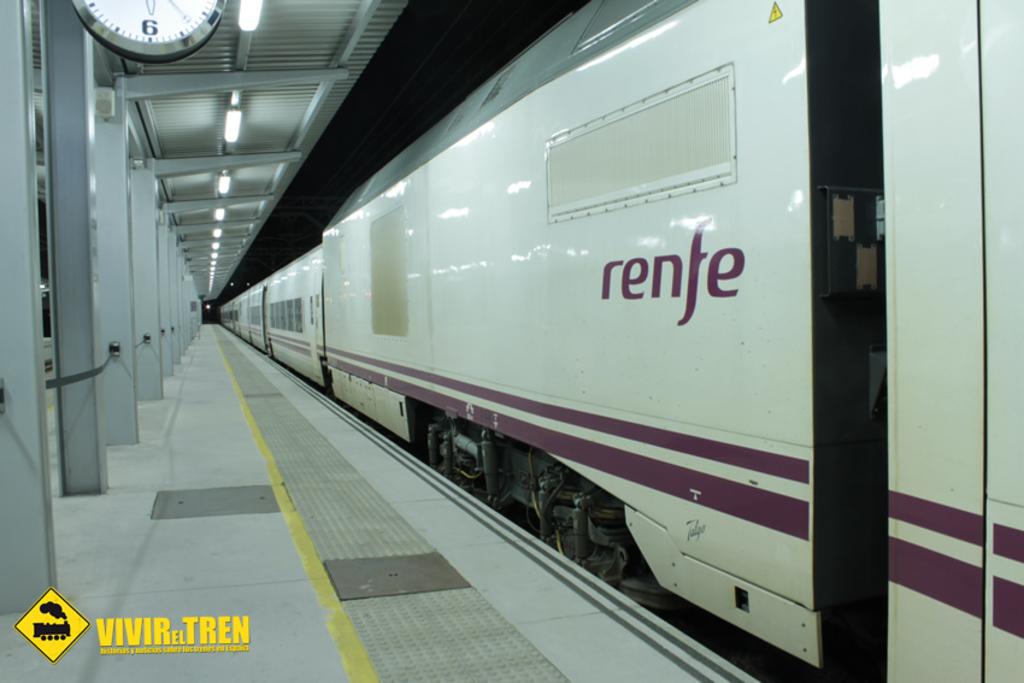What is the name on the side of the train?
Make the answer very short. Renfe. What number is shown on the clock?
Your answer should be compact. 6. 